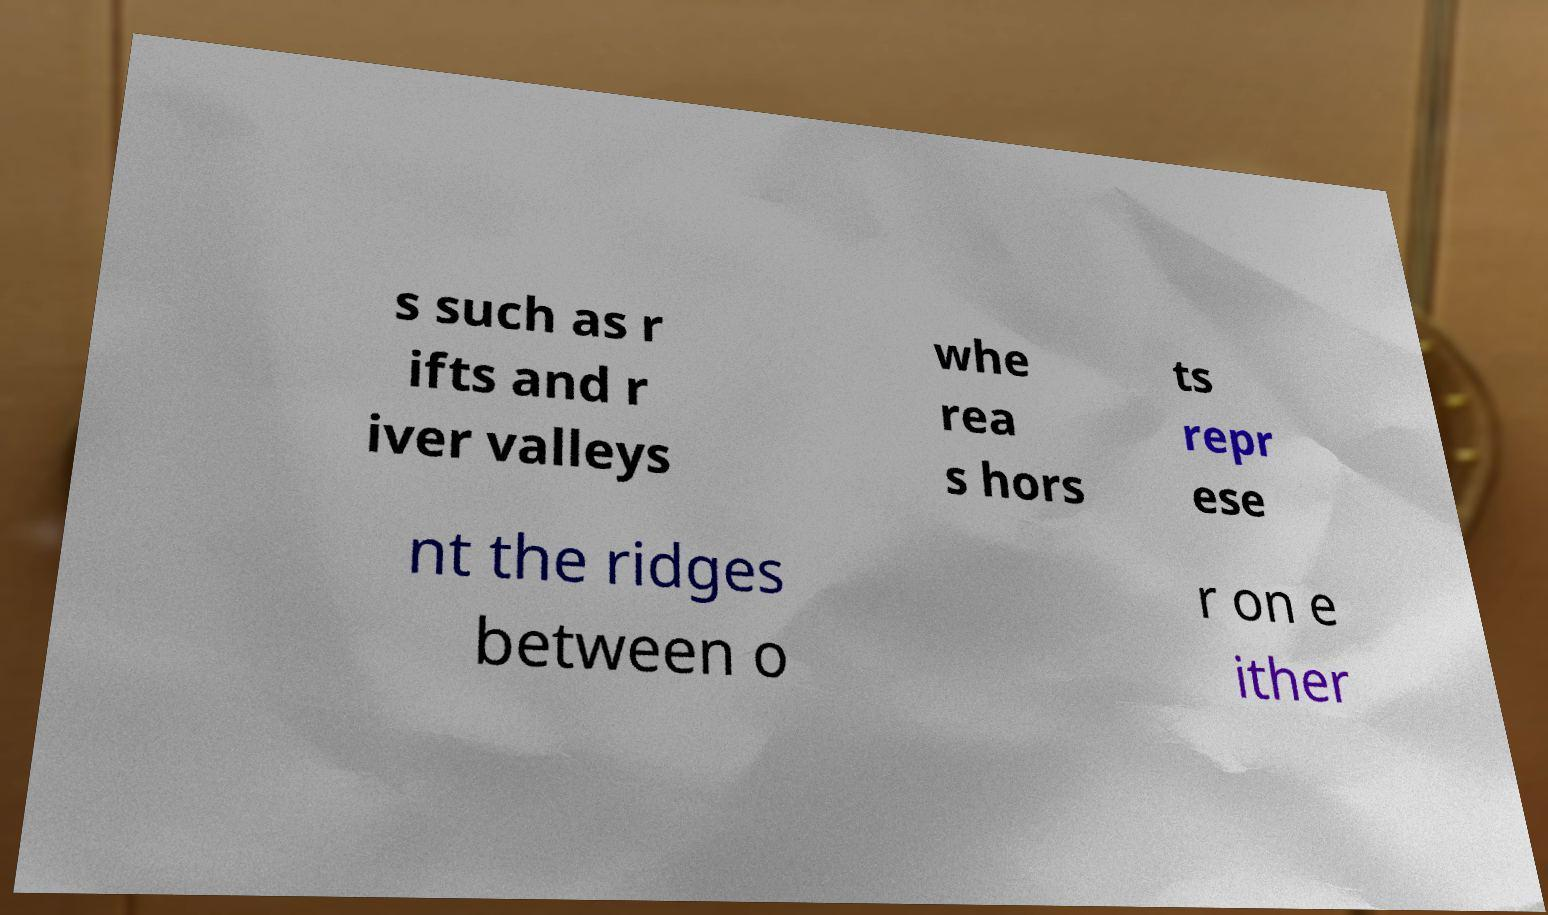Please identify and transcribe the text found in this image. s such as r ifts and r iver valleys whe rea s hors ts repr ese nt the ridges between o r on e ither 